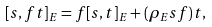<formula> <loc_0><loc_0><loc_500><loc_500>[ s , f t ] _ { E } = f [ s , t ] _ { E } + ( \rho _ { E } s f ) t ,</formula> 